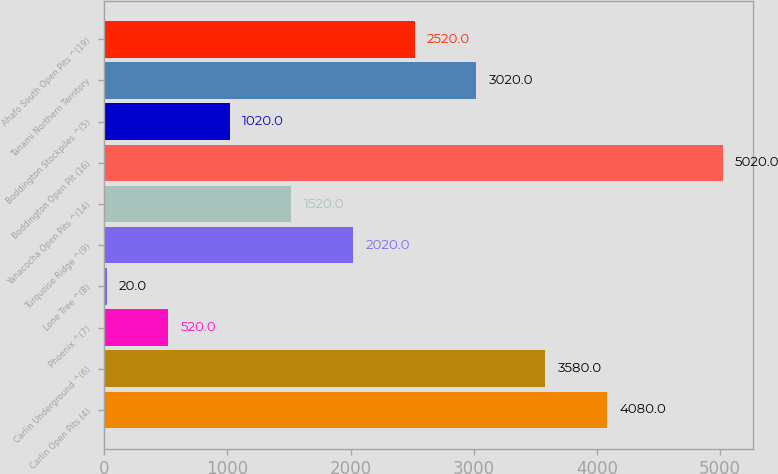Convert chart. <chart><loc_0><loc_0><loc_500><loc_500><bar_chart><fcel>Carlin Open Pits (4)<fcel>Carlin Underground ^(6)<fcel>Phoenix ^(7)<fcel>Lone Tree ^(8)<fcel>Turquoise Ridge ^(9)<fcel>Yanacocha Open Pits ^(14)<fcel>Boddington Open Pit (16)<fcel>Boddington Stockpiles ^(5)<fcel>Tanami Northern Territory<fcel>Ahafo South Open Pits ^(19)<nl><fcel>4080<fcel>3580<fcel>520<fcel>20<fcel>2020<fcel>1520<fcel>5020<fcel>1020<fcel>3020<fcel>2520<nl></chart> 